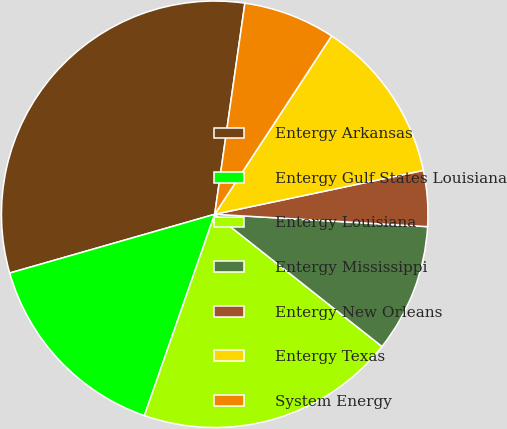Convert chart to OTSL. <chart><loc_0><loc_0><loc_500><loc_500><pie_chart><fcel>Entergy Arkansas<fcel>Entergy Gulf States Louisiana<fcel>Entergy Louisiana<fcel>Entergy Mississippi<fcel>Entergy New Orleans<fcel>Entergy Texas<fcel>System Energy<nl><fcel>31.7%<fcel>15.21%<fcel>19.7%<fcel>9.72%<fcel>4.22%<fcel>12.47%<fcel>6.97%<nl></chart> 